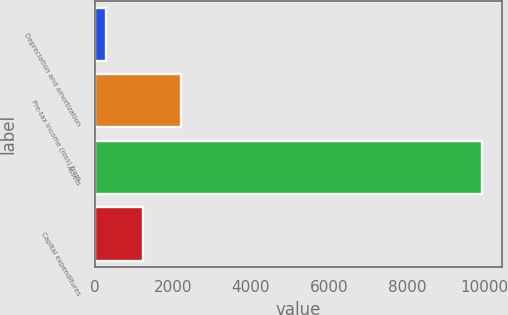Convert chart to OTSL. <chart><loc_0><loc_0><loc_500><loc_500><bar_chart><fcel>Depreciation and amortization<fcel>Pre-tax income (loss) from<fcel>Assets<fcel>Capital expenditures<nl><fcel>285<fcel>2215.2<fcel>9936<fcel>1250.1<nl></chart> 